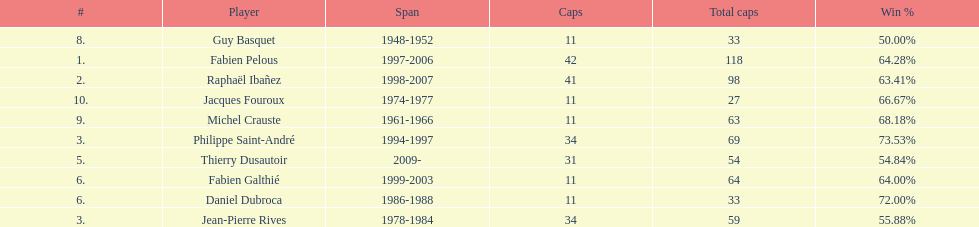Who had the largest win percentage? Philippe Saint-André. Help me parse the entirety of this table. {'header': ['#', 'Player', 'Span', 'Caps', 'Total caps', 'Win\xa0%'], 'rows': [['8.', 'Guy Basquet', '1948-1952', '11', '33', '50.00%'], ['1.', 'Fabien Pelous', '1997-2006', '42', '118', '64.28%'], ['2.', 'Raphaël Ibañez', '1998-2007', '41', '98', '63.41%'], ['10.', 'Jacques Fouroux', '1974-1977', '11', '27', '66.67%'], ['9.', 'Michel Crauste', '1961-1966', '11', '63', '68.18%'], ['3.', 'Philippe Saint-André', '1994-1997', '34', '69', '73.53%'], ['5.', 'Thierry Dusautoir', '2009-', '31', '54', '54.84%'], ['6.', 'Fabien Galthié', '1999-2003', '11', '64', '64.00%'], ['6.', 'Daniel Dubroca', '1986-1988', '11', '33', '72.00%'], ['3.', 'Jean-Pierre Rives', '1978-1984', '34', '59', '55.88%']]} 